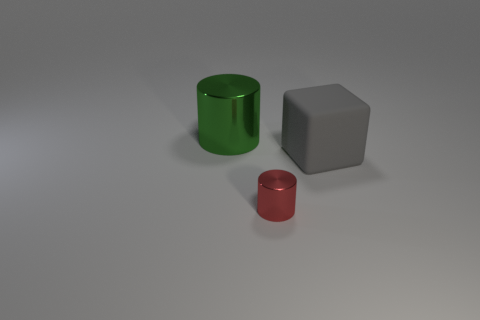Add 3 big cubes. How many objects exist? 6 Subtract all blocks. How many objects are left? 2 Add 2 big purple objects. How many big purple objects exist? 2 Subtract 0 yellow cubes. How many objects are left? 3 Subtract all tiny brown blocks. Subtract all large objects. How many objects are left? 1 Add 2 small shiny cylinders. How many small shiny cylinders are left? 3 